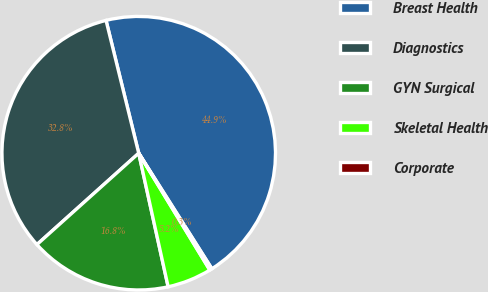Convert chart to OTSL. <chart><loc_0><loc_0><loc_500><loc_500><pie_chart><fcel>Breast Health<fcel>Diagnostics<fcel>GYN Surgical<fcel>Skeletal Health<fcel>Corporate<nl><fcel>44.86%<fcel>32.8%<fcel>16.81%<fcel>5.25%<fcel>0.28%<nl></chart> 